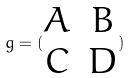<formula> <loc_0><loc_0><loc_500><loc_500>g = ( \begin{matrix} A & B \\ C & D \end{matrix} )</formula> 